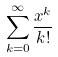Convert formula to latex. <formula><loc_0><loc_0><loc_500><loc_500>\sum _ { k = 0 } ^ { \infty } \frac { x ^ { k } } { k ! }</formula> 